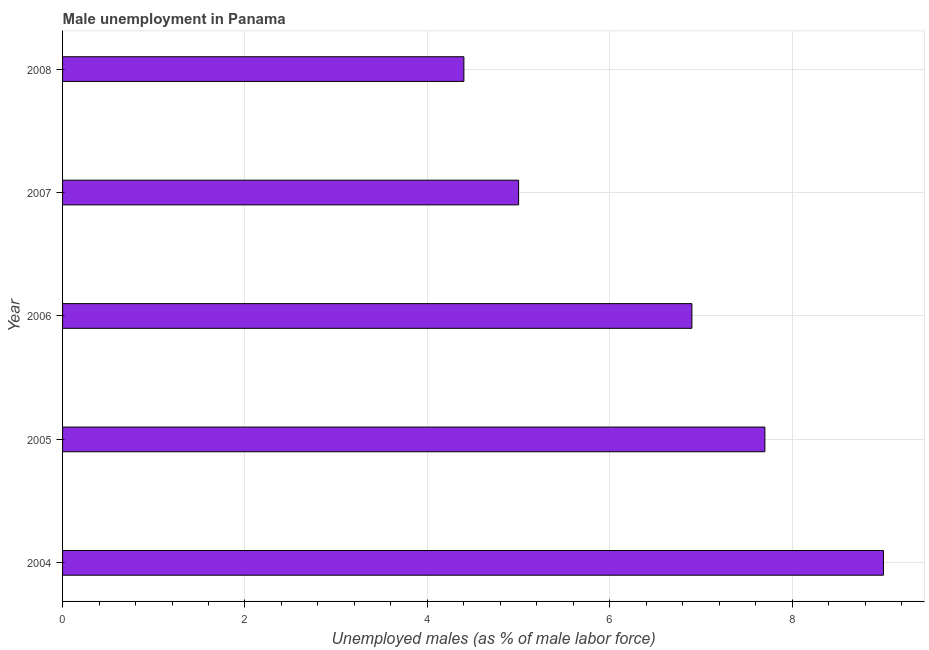Does the graph contain grids?
Make the answer very short. Yes. What is the title of the graph?
Your answer should be compact. Male unemployment in Panama. What is the label or title of the X-axis?
Your response must be concise. Unemployed males (as % of male labor force). What is the label or title of the Y-axis?
Give a very brief answer. Year. What is the unemployed males population in 2006?
Make the answer very short. 6.9. Across all years, what is the maximum unemployed males population?
Make the answer very short. 9. Across all years, what is the minimum unemployed males population?
Offer a very short reply. 4.4. In which year was the unemployed males population minimum?
Ensure brevity in your answer.  2008. What is the median unemployed males population?
Ensure brevity in your answer.  6.9. In how many years, is the unemployed males population greater than 7.2 %?
Provide a short and direct response. 2. Do a majority of the years between 2006 and 2005 (inclusive) have unemployed males population greater than 6.8 %?
Keep it short and to the point. No. What is the ratio of the unemployed males population in 2004 to that in 2008?
Provide a succinct answer. 2.04. Is the unemployed males population in 2006 less than that in 2008?
Keep it short and to the point. No. What is the difference between the highest and the lowest unemployed males population?
Keep it short and to the point. 4.6. In how many years, is the unemployed males population greater than the average unemployed males population taken over all years?
Ensure brevity in your answer.  3. How many years are there in the graph?
Ensure brevity in your answer.  5. Are the values on the major ticks of X-axis written in scientific E-notation?
Provide a short and direct response. No. What is the Unemployed males (as % of male labor force) of 2005?
Ensure brevity in your answer.  7.7. What is the Unemployed males (as % of male labor force) in 2006?
Keep it short and to the point. 6.9. What is the Unemployed males (as % of male labor force) in 2007?
Provide a succinct answer. 5. What is the Unemployed males (as % of male labor force) of 2008?
Provide a succinct answer. 4.4. What is the difference between the Unemployed males (as % of male labor force) in 2004 and 2006?
Your answer should be compact. 2.1. What is the difference between the Unemployed males (as % of male labor force) in 2005 and 2006?
Ensure brevity in your answer.  0.8. What is the difference between the Unemployed males (as % of male labor force) in 2005 and 2008?
Provide a short and direct response. 3.3. What is the difference between the Unemployed males (as % of male labor force) in 2006 and 2008?
Give a very brief answer. 2.5. What is the difference between the Unemployed males (as % of male labor force) in 2007 and 2008?
Offer a terse response. 0.6. What is the ratio of the Unemployed males (as % of male labor force) in 2004 to that in 2005?
Offer a very short reply. 1.17. What is the ratio of the Unemployed males (as % of male labor force) in 2004 to that in 2006?
Offer a very short reply. 1.3. What is the ratio of the Unemployed males (as % of male labor force) in 2004 to that in 2008?
Your answer should be very brief. 2.04. What is the ratio of the Unemployed males (as % of male labor force) in 2005 to that in 2006?
Provide a short and direct response. 1.12. What is the ratio of the Unemployed males (as % of male labor force) in 2005 to that in 2007?
Give a very brief answer. 1.54. What is the ratio of the Unemployed males (as % of male labor force) in 2006 to that in 2007?
Offer a very short reply. 1.38. What is the ratio of the Unemployed males (as % of male labor force) in 2006 to that in 2008?
Offer a very short reply. 1.57. What is the ratio of the Unemployed males (as % of male labor force) in 2007 to that in 2008?
Your answer should be very brief. 1.14. 